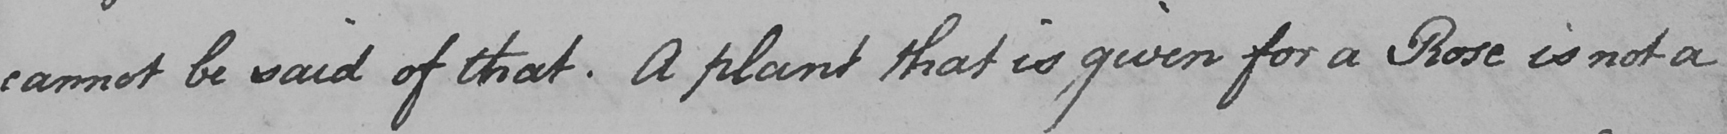Transcribe the text shown in this historical manuscript line. cannot be said of that . A plant that is given for a Rose is not a 